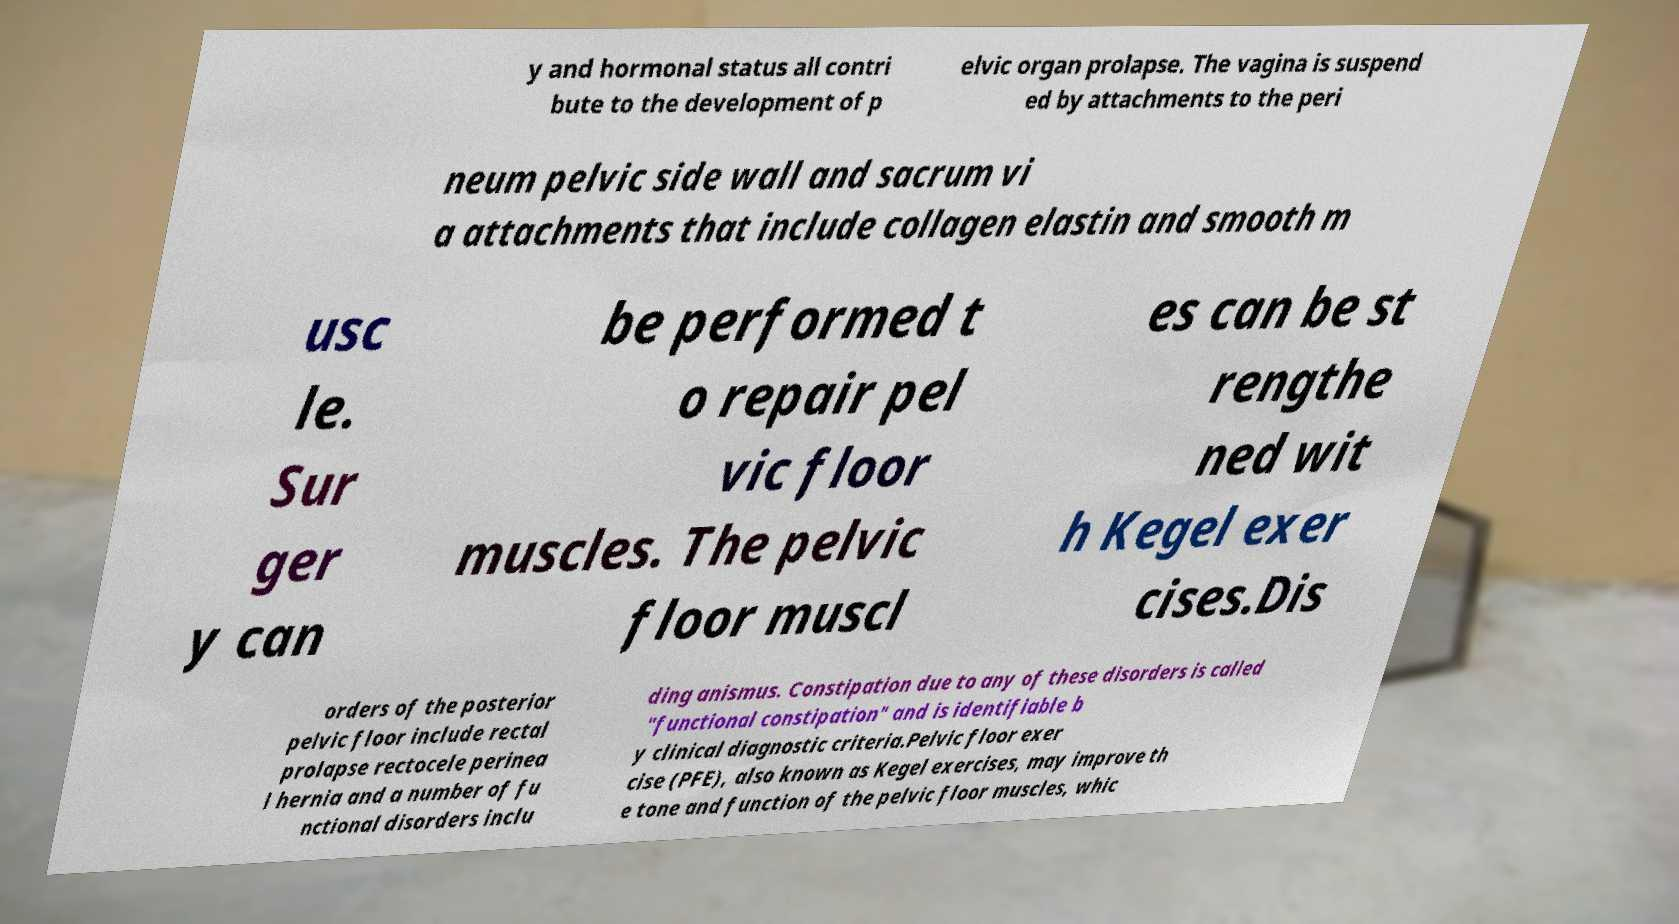Please read and relay the text visible in this image. What does it say? y and hormonal status all contri bute to the development of p elvic organ prolapse. The vagina is suspend ed by attachments to the peri neum pelvic side wall and sacrum vi a attachments that include collagen elastin and smooth m usc le. Sur ger y can be performed t o repair pel vic floor muscles. The pelvic floor muscl es can be st rengthe ned wit h Kegel exer cises.Dis orders of the posterior pelvic floor include rectal prolapse rectocele perinea l hernia and a number of fu nctional disorders inclu ding anismus. Constipation due to any of these disorders is called "functional constipation" and is identifiable b y clinical diagnostic criteria.Pelvic floor exer cise (PFE), also known as Kegel exercises, may improve th e tone and function of the pelvic floor muscles, whic 